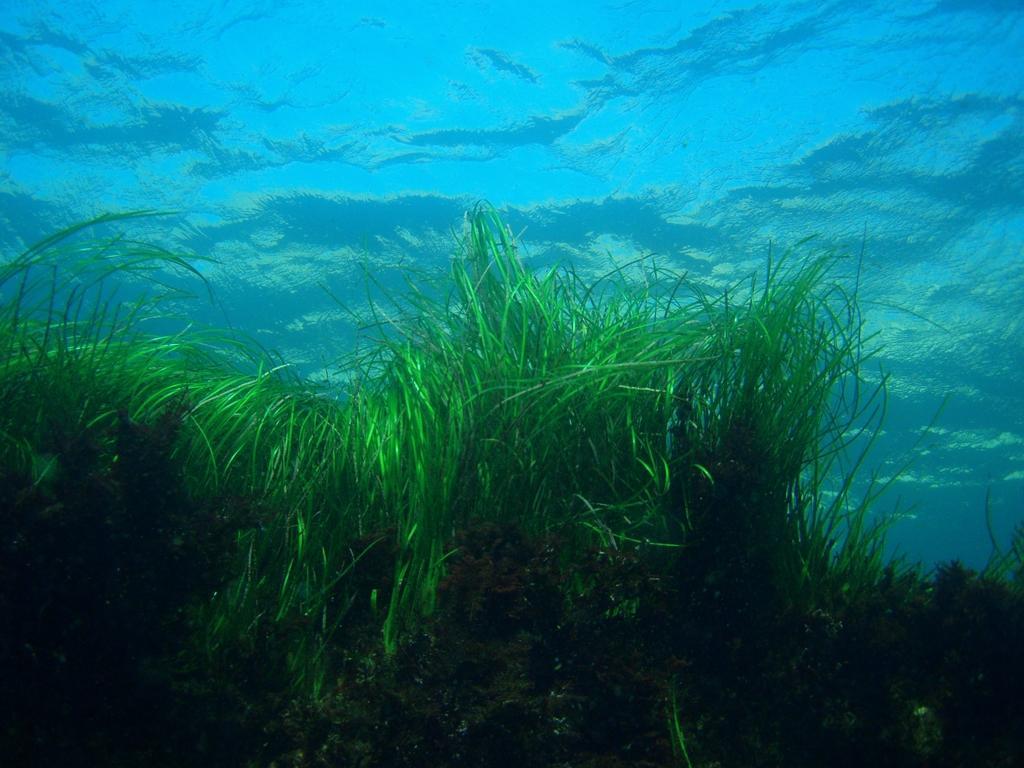Can you describe this image briefly? In the image there is water. Inside the water to the bottom of the image there is grass. 